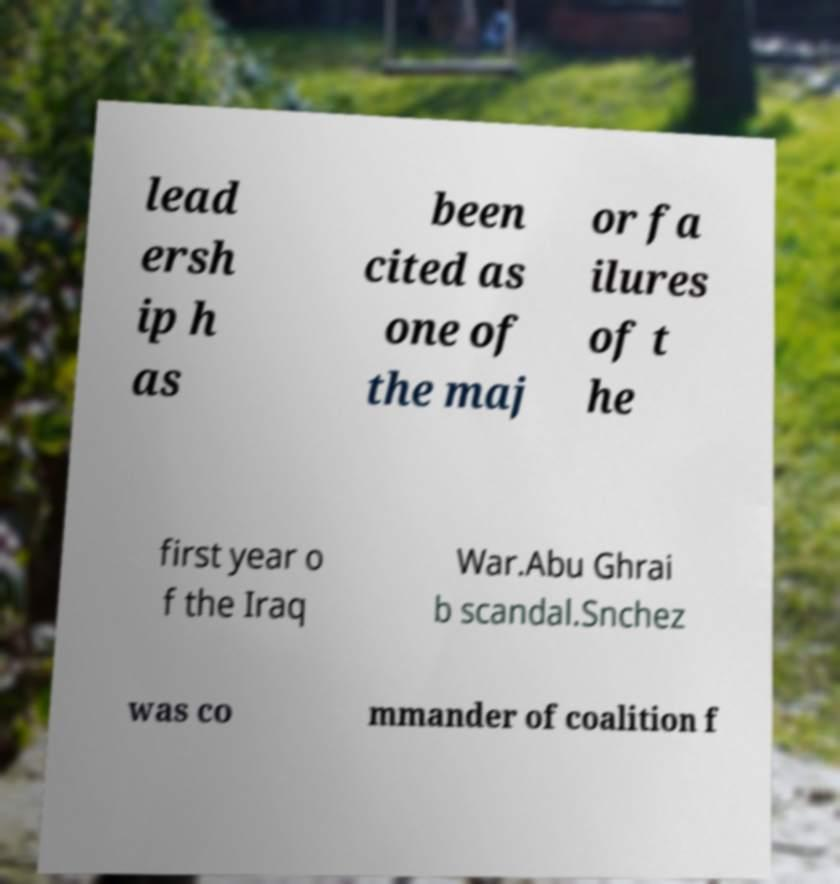What messages or text are displayed in this image? I need them in a readable, typed format. lead ersh ip h as been cited as one of the maj or fa ilures of t he first year o f the Iraq War.Abu Ghrai b scandal.Snchez was co mmander of coalition f 